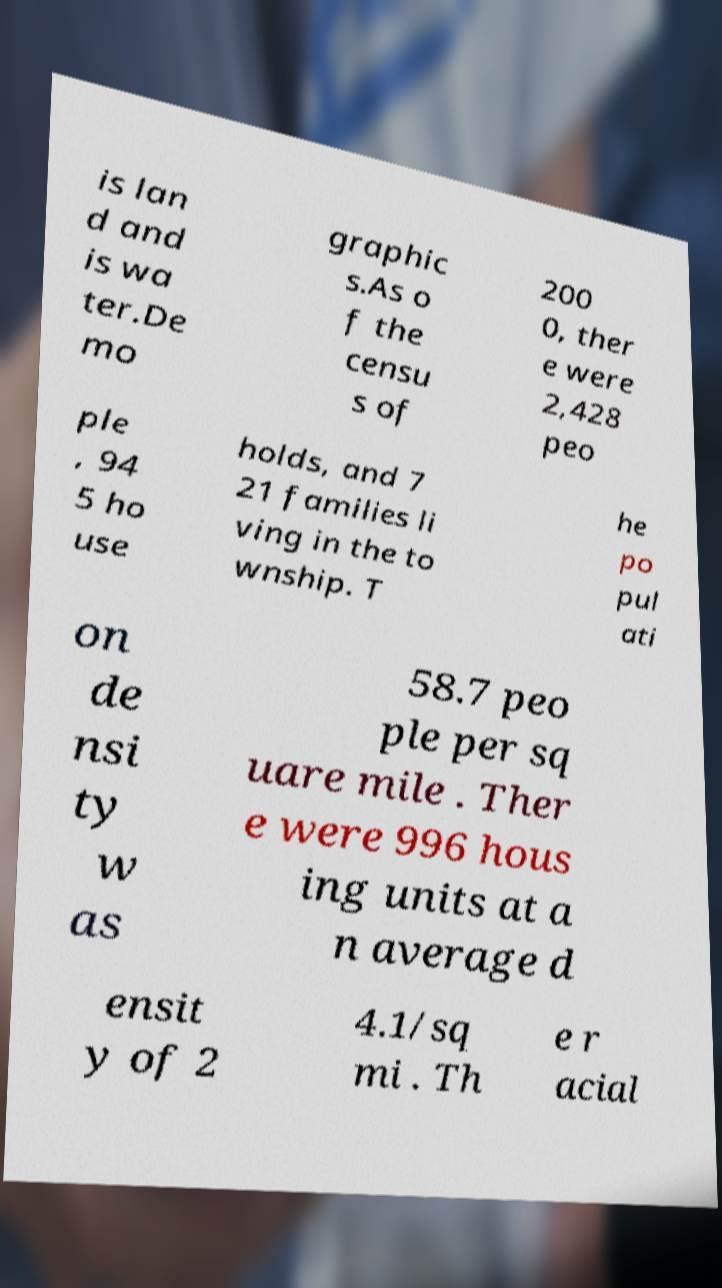Could you assist in decoding the text presented in this image and type it out clearly? is lan d and is wa ter.De mo graphic s.As o f the censu s of 200 0, ther e were 2,428 peo ple , 94 5 ho use holds, and 7 21 families li ving in the to wnship. T he po pul ati on de nsi ty w as 58.7 peo ple per sq uare mile . Ther e were 996 hous ing units at a n average d ensit y of 2 4.1/sq mi . Th e r acial 